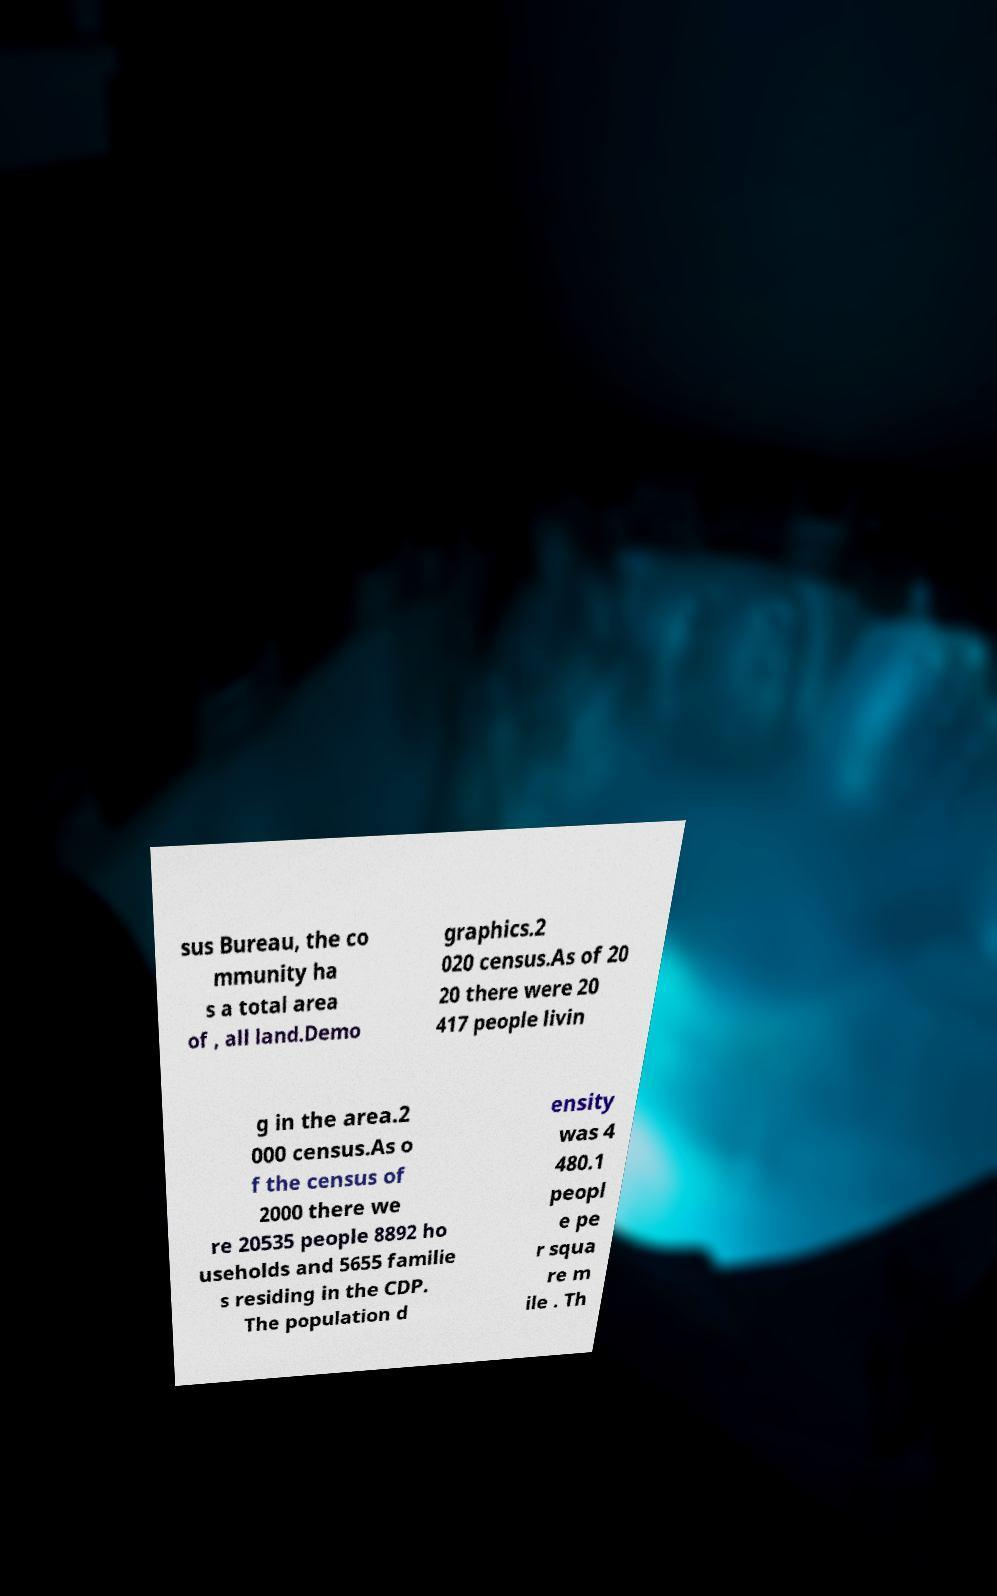Could you assist in decoding the text presented in this image and type it out clearly? sus Bureau, the co mmunity ha s a total area of , all land.Demo graphics.2 020 census.As of 20 20 there were 20 417 people livin g in the area.2 000 census.As o f the census of 2000 there we re 20535 people 8892 ho useholds and 5655 familie s residing in the CDP. The population d ensity was 4 480.1 peopl e pe r squa re m ile . Th 